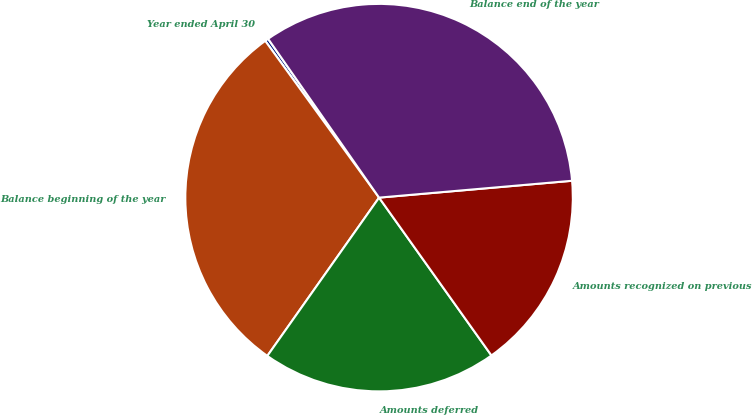Convert chart to OTSL. <chart><loc_0><loc_0><loc_500><loc_500><pie_chart><fcel>Year ended April 30<fcel>Balance beginning of the year<fcel>Amounts deferred<fcel>Amounts recognized on previous<fcel>Balance end of the year<nl><fcel>0.29%<fcel>30.22%<fcel>19.63%<fcel>16.54%<fcel>33.32%<nl></chart> 